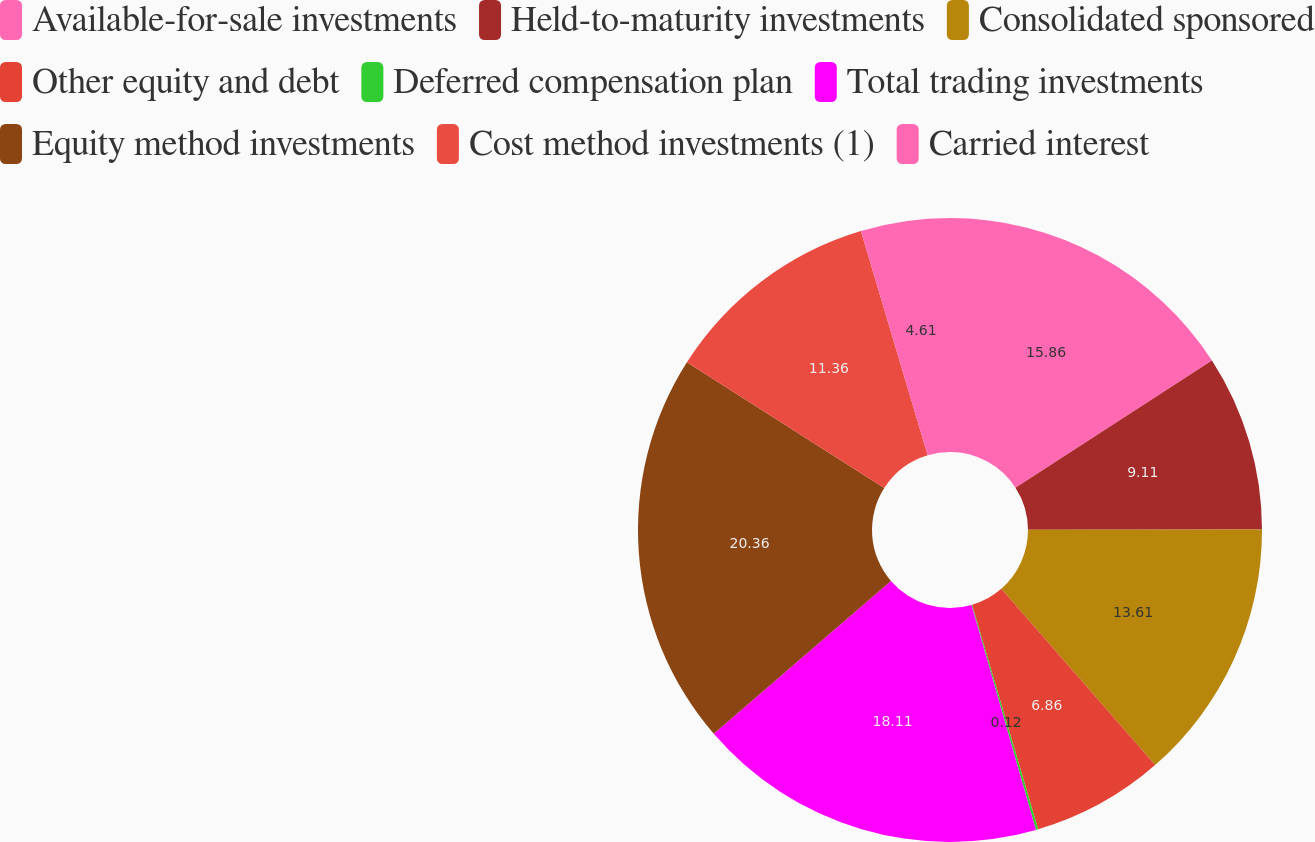Convert chart to OTSL. <chart><loc_0><loc_0><loc_500><loc_500><pie_chart><fcel>Available-for-sale investments<fcel>Held-to-maturity investments<fcel>Consolidated sponsored<fcel>Other equity and debt<fcel>Deferred compensation plan<fcel>Total trading investments<fcel>Equity method investments<fcel>Cost method investments (1)<fcel>Carried interest<nl><fcel>15.86%<fcel>9.11%<fcel>13.61%<fcel>6.86%<fcel>0.12%<fcel>18.11%<fcel>20.36%<fcel>11.36%<fcel>4.61%<nl></chart> 